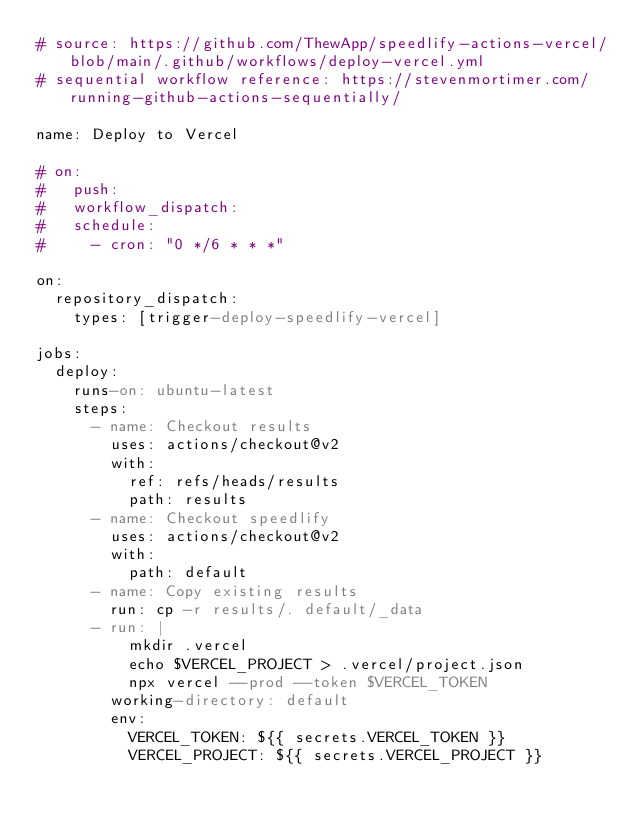Convert code to text. <code><loc_0><loc_0><loc_500><loc_500><_YAML_># source: https://github.com/ThewApp/speedlify-actions-vercel/blob/main/.github/workflows/deploy-vercel.yml
# sequential workflow reference: https://stevenmortimer.com/running-github-actions-sequentially/

name: Deploy to Vercel

# on:
#   push:
#   workflow_dispatch:
#   schedule:
#     - cron: "0 */6 * * *"

on:
  repository_dispatch:
    types: [trigger-deploy-speedlify-vercel]

jobs:
  deploy:
    runs-on: ubuntu-latest
    steps:
      - name: Checkout results
        uses: actions/checkout@v2
        with:
          ref: refs/heads/results
          path: results
      - name: Checkout speedlify
        uses: actions/checkout@v2
        with:
          path: default
      - name: Copy existing results
        run: cp -r results/. default/_data
      - run: |
          mkdir .vercel
          echo $VERCEL_PROJECT > .vercel/project.json
          npx vercel --prod --token $VERCEL_TOKEN
        working-directory: default
        env:
          VERCEL_TOKEN: ${{ secrets.VERCEL_TOKEN }}
          VERCEL_PROJECT: ${{ secrets.VERCEL_PROJECT }}
</code> 